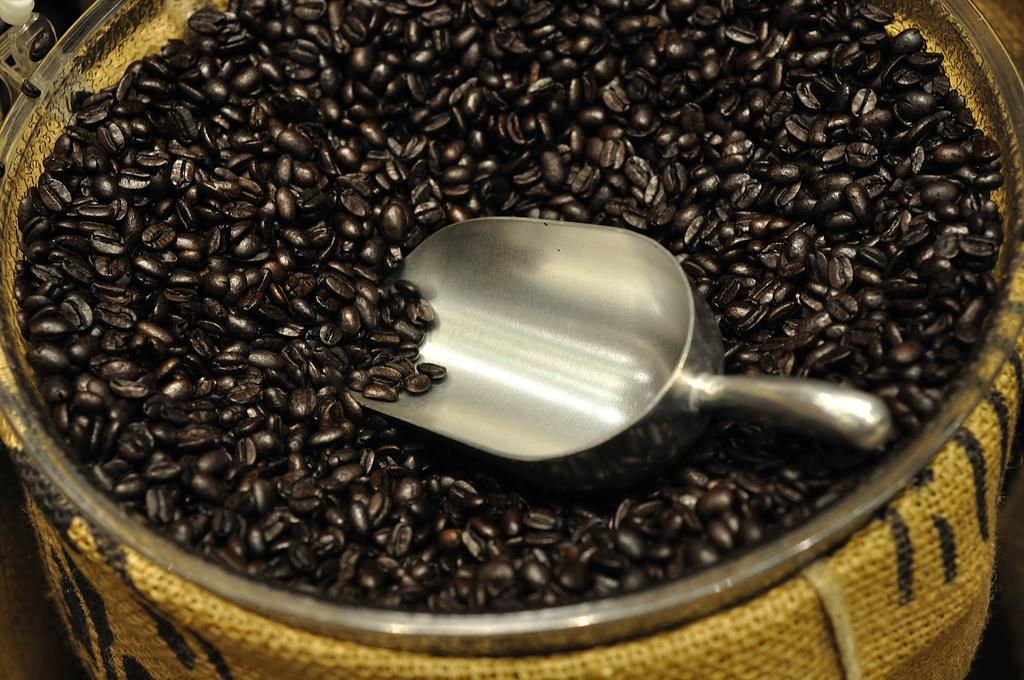What type of beans are featured in the image? There are coffee beans in the image. What color are the coffee beans? The coffee beans are black in color. How many chickens are present in the image? There are no chickens present in the image; it features coffee beans. What type of bottle is visible in the image? There is no bottle present in the image; it features coffee beans. 